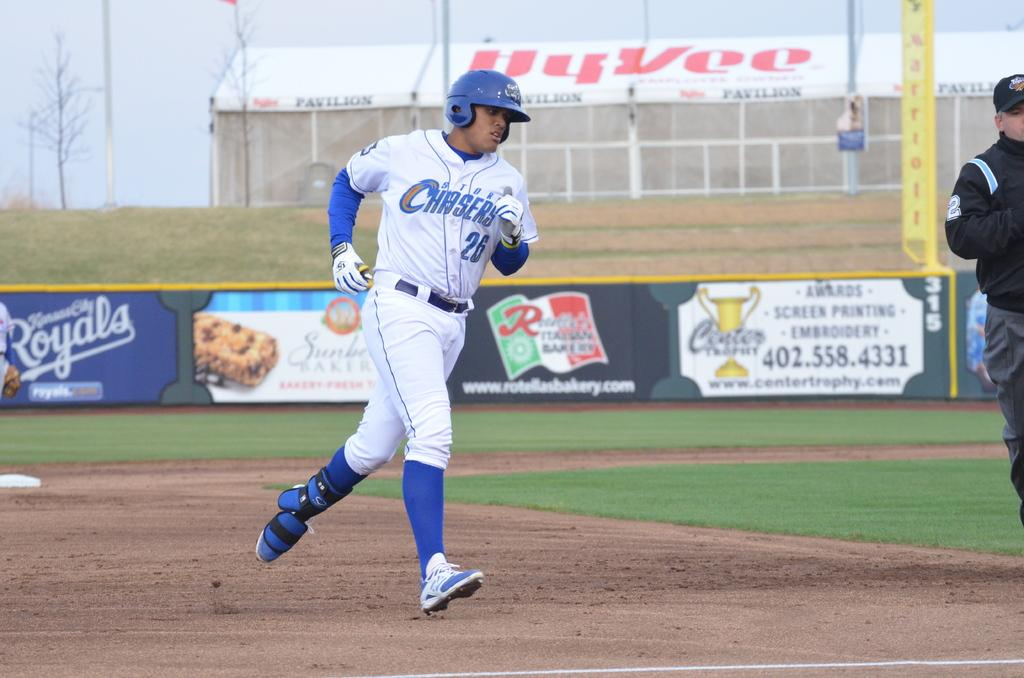<image>
Share a concise interpretation of the image provided. a baseball player wearing the number 26 storm chasers jersey 